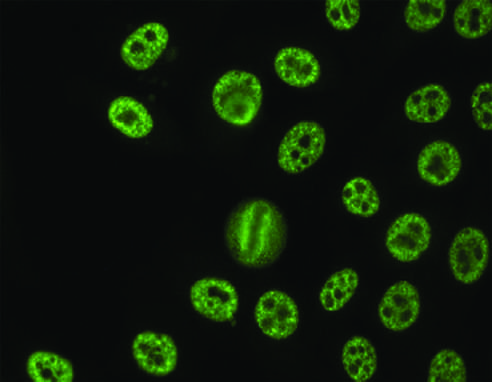s a speckled pattern seen with antibodies against various nuclear antigens, including sm and rnps?
Answer the question using a single word or phrase. Yes 